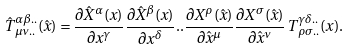<formula> <loc_0><loc_0><loc_500><loc_500>\hat { T } ^ { \alpha \beta . . } _ { \, \mu \nu . . } ( \hat { x } ) = \frac { \partial \hat { X } ^ { \alpha } ( x ) } { \partial x ^ { \gamma } } \frac { \partial \hat { X } ^ { \beta } ( x ) } { \partial x ^ { \delta } } . . \frac { \partial X ^ { \rho } ( \hat { x } ) } { \partial \hat { x } ^ { \mu } } \frac { \partial X ^ { \sigma } ( \hat { x } ) } { \partial \hat { x } ^ { \nu } } \, T ^ { \gamma \delta . . } _ { \, \rho \sigma . . } ( x ) .</formula> 